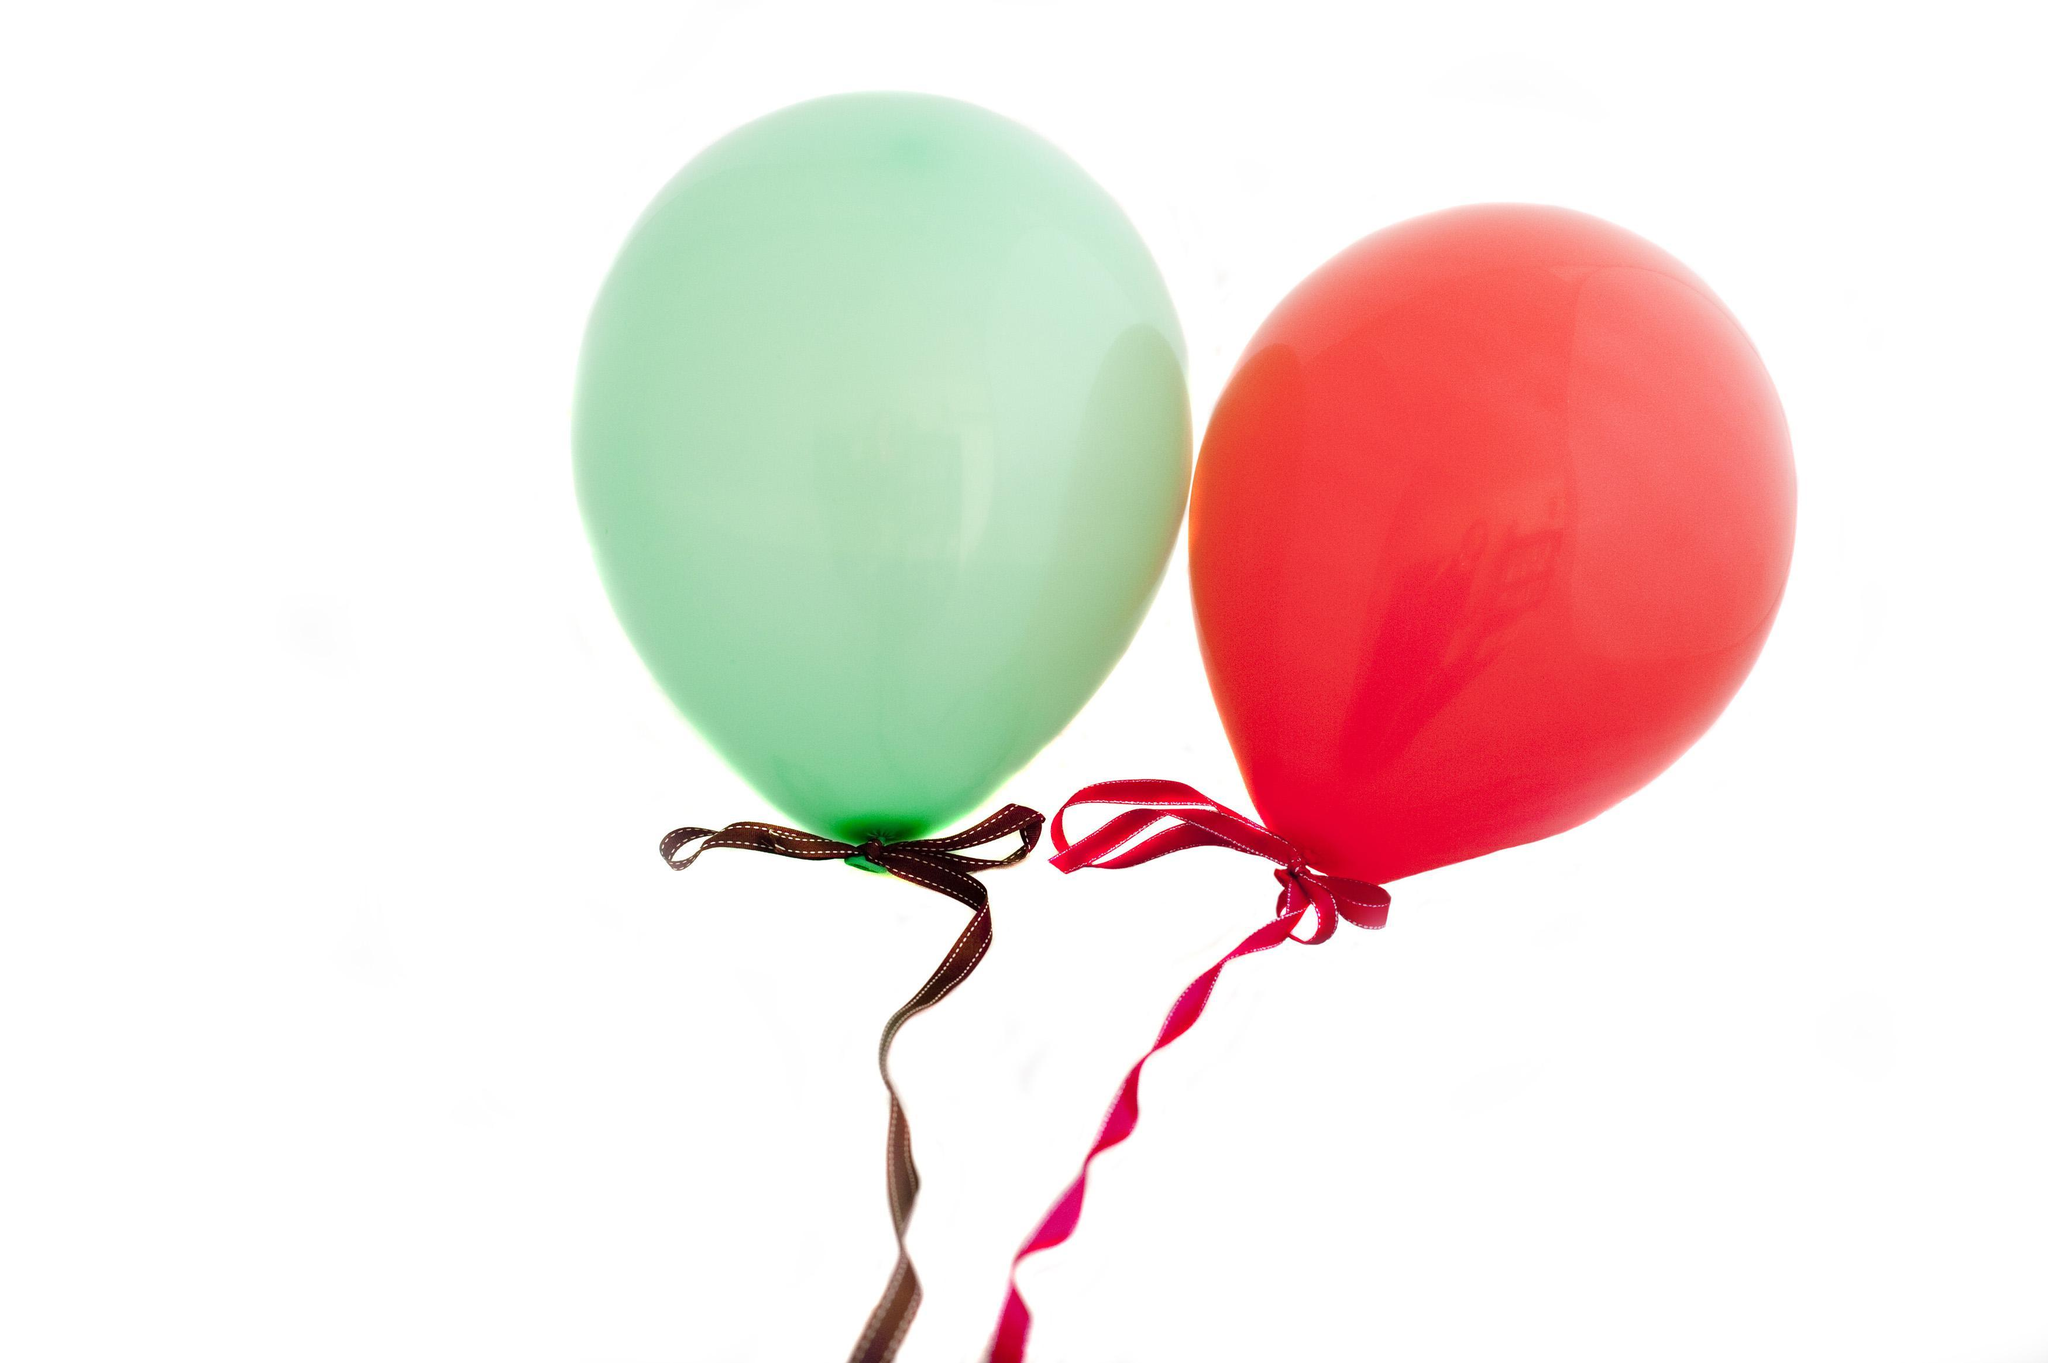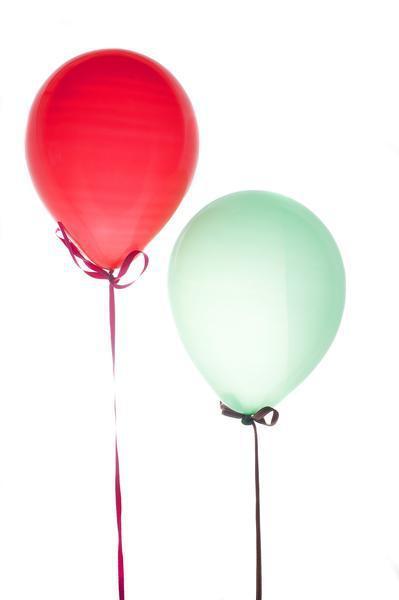The first image is the image on the left, the second image is the image on the right. Assess this claim about the two images: "There is a heart shaped balloon". Correct or not? Answer yes or no. No. The first image is the image on the left, the second image is the image on the right. Analyze the images presented: Is the assertion "There are two red balloons and two green balloons" valid? Answer yes or no. Yes. 